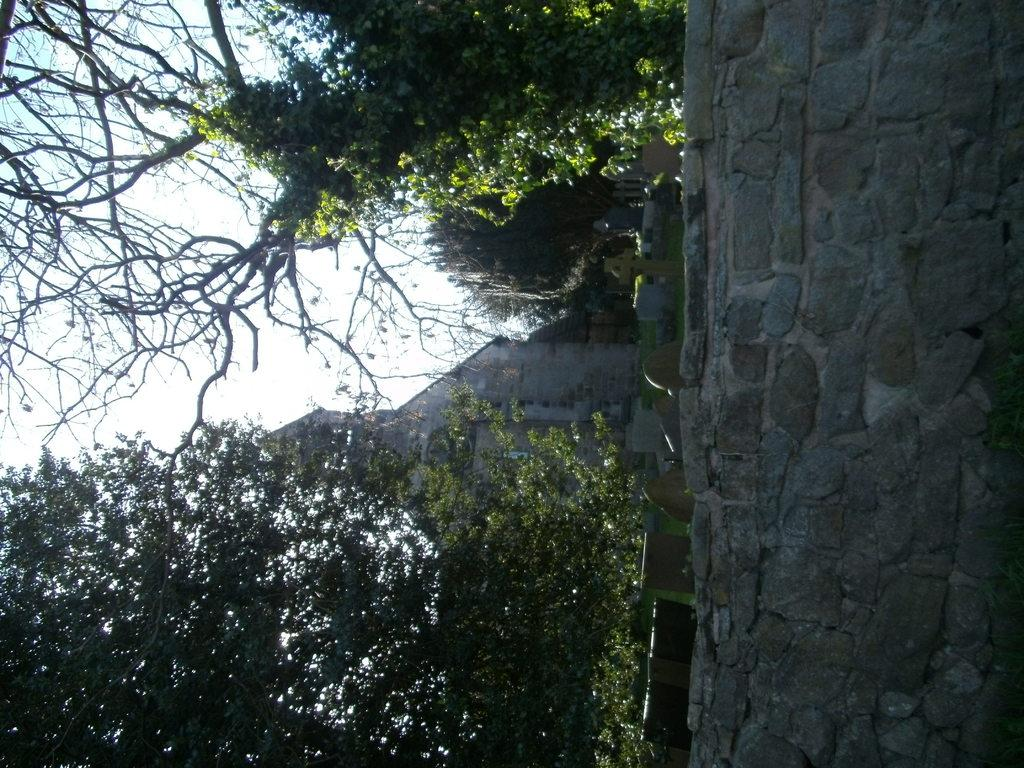What type of structure is present in the image? There is a building in the image. What type of natural elements are visible in the image? There are trees in the image. What type of man-made structure is present in the image? There is a wall in the image. What type of burial site is present in the image? There is a grave in the image. What part of the natural environment is visible in the image? The sky is visible in the image. What type of circle can be seen in the image? There is no circle present in the image. What type of experience can be gained from visiting the grave in the image? The image does not provide information about the experience of visiting the grave. What type of arm is visible in the image? There is no arm present in the image. 